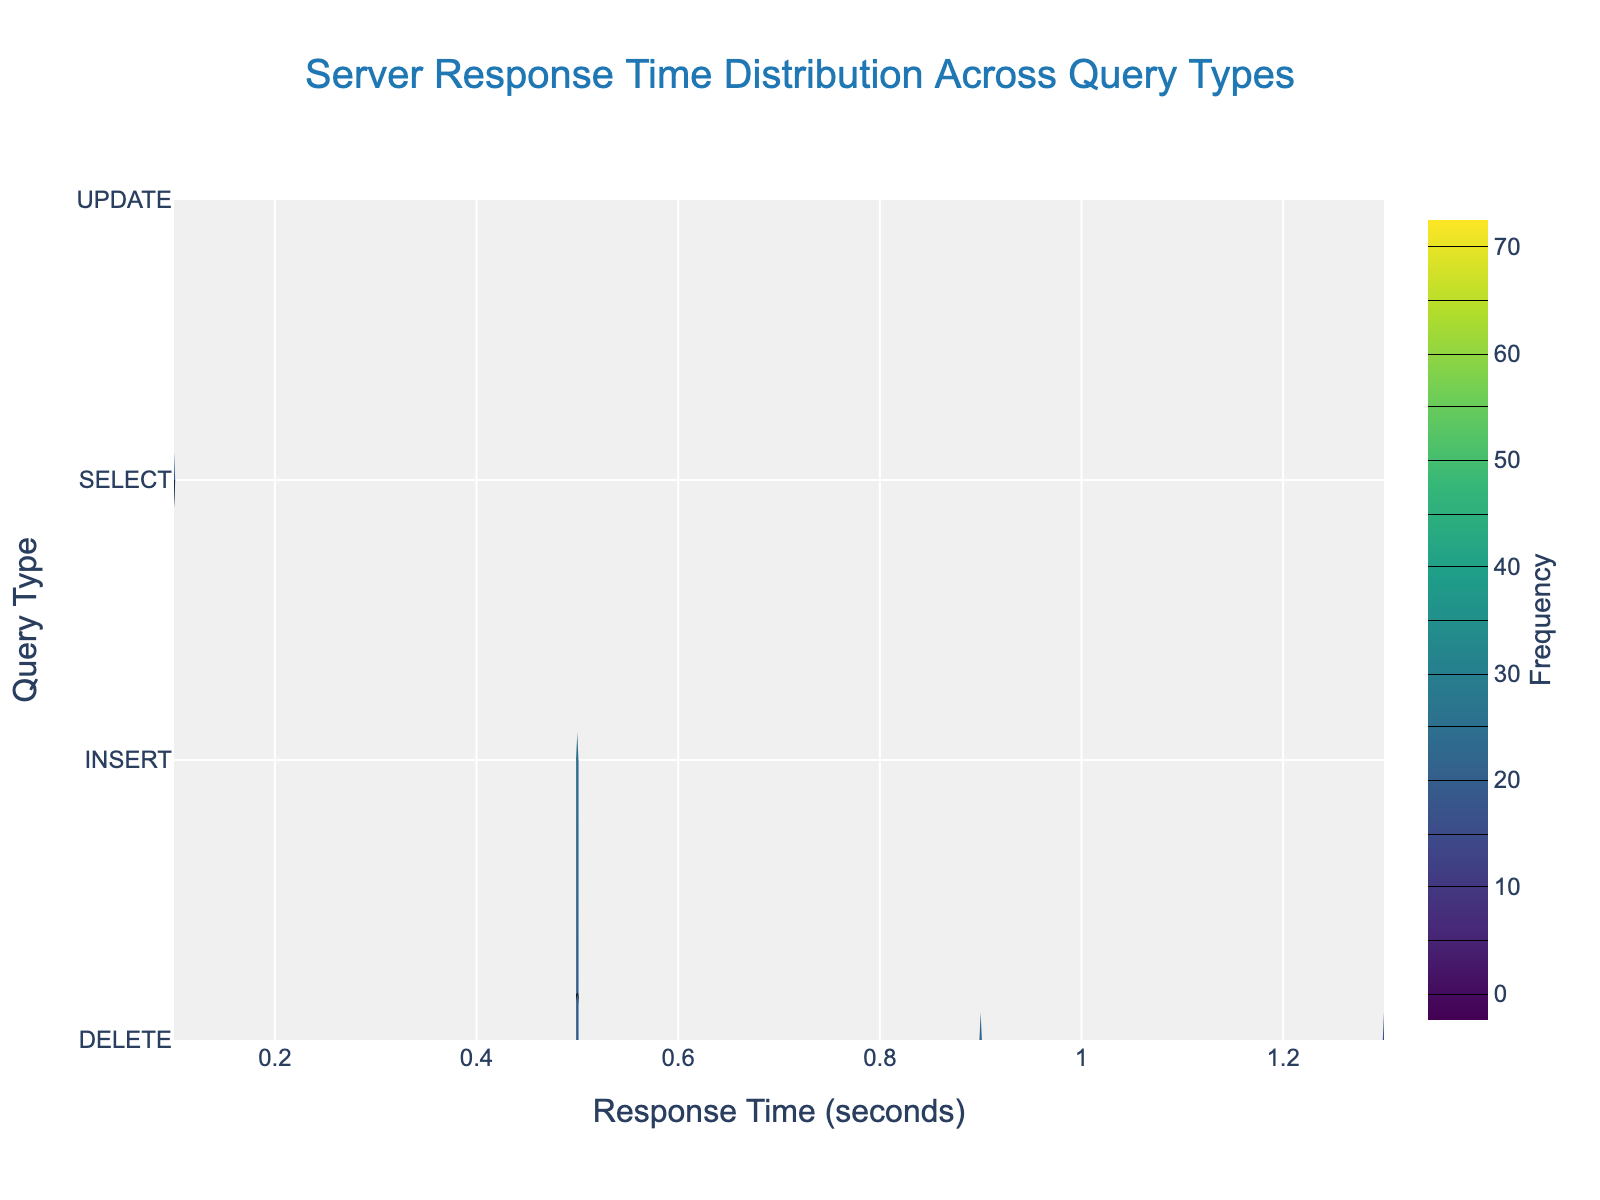How many different Query Types are represented in the figure? The y-axis lists the different query types. By counting the unique labels on the y-axis, we can determine the number of Query Types.
Answer: 4 What is the title of the figure? The figure's title is usually located at the top of the plot.
Answer: Server Response Time Distribution Across Query Types Which Query Type has the highest frequency for the fastest response time? The fastest response time is the lowest value on the x-axis. At the lowest x-value, identify which Query Type has the highest frequency indicated by contour lines or color intensity.
Answer: SELECT At what response time does the SELECT query type experience the highest frequency? Look at the SELECT Query Type on the y-axis and follow the point with the highest contour or color intensity to the x-axis.
Answer: 1.2 seconds How do the response times of INSERT and UPDATE queries compare at their respective highest frequencies? First, identify the x-values at the points of highest frequency for INSERT and UPDATE by looking at the most intense contour area for each. Then, compare these x-values.
Answer: INSERT: 1.0 seconds, UPDATE: 1.1 seconds Which Query Type has the widest range of response times? Look at the span of the x-axis for each query type from the lowest to the highest x-values that have contour lines. The query covering the most range on the x-axis has the widest range of response times.
Answer: SELECT For the DELETE query type, what is the frequency at a response time of 0.9 seconds? Follow the point y = DELETE on the y-axis to the x = 0.9 seconds on the x-axis and check the contour value or color intensity at this location.
Answer: 22 Is there a response time where all four Query Types show significant frequency? Trace along the x-axis to see if there's an x-value where contours for all query types (INSERT, SELECT, UPDATE, DELETE) are noticeable.
Answer: No Which Query Type shows the least variability in response time? Identify the query type with the narrowest span of x-values where contour lines or color intensity are noticeable. The query covering the smallest range on the x-axis shows the least variability.
Answer: INSERT At what response time do INSERT and DELETE queries have nearly the same frequency? Look at their respective contours or color intensity levels along the x-axis to find an x-value where both query types have similar frequencies.
Answer: 0.5 seconds 